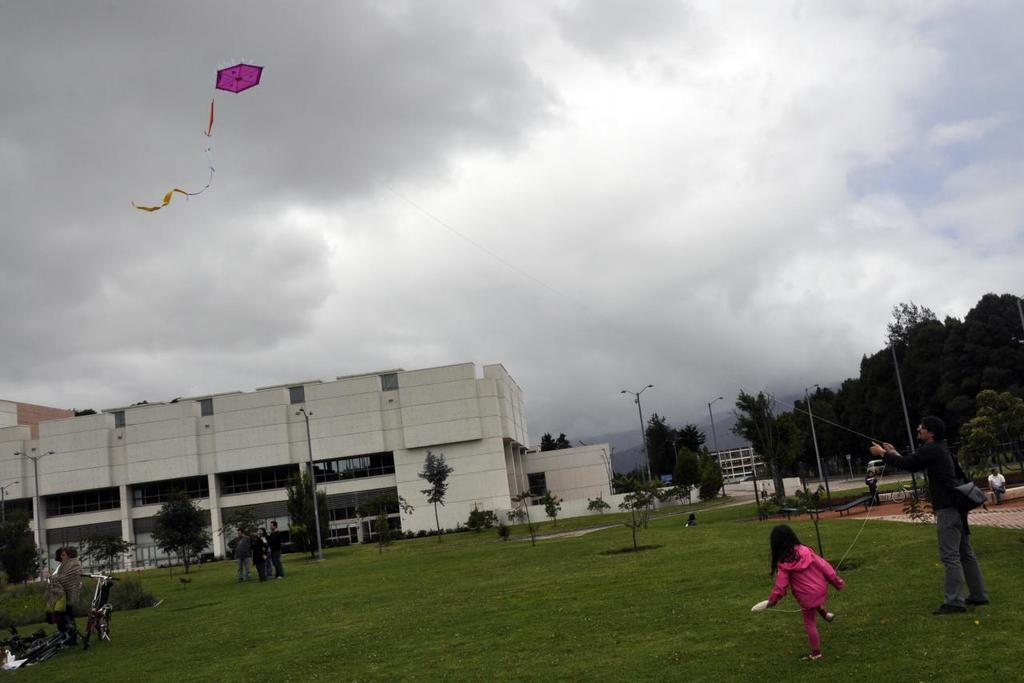Please provide a concise description of this image. This picture is clicked outside. In the foreground we can see the green grass, group of persons and we can see a bicycle, lamp posts, plants, trees, buildings and some other objects. On the right corner we can see a person wearing sling bag, standing on the ground and seems to be flying the kite in the sky. In the background we can see the sky which is full of clouds and we can see the trees, buildings and some other objects. 